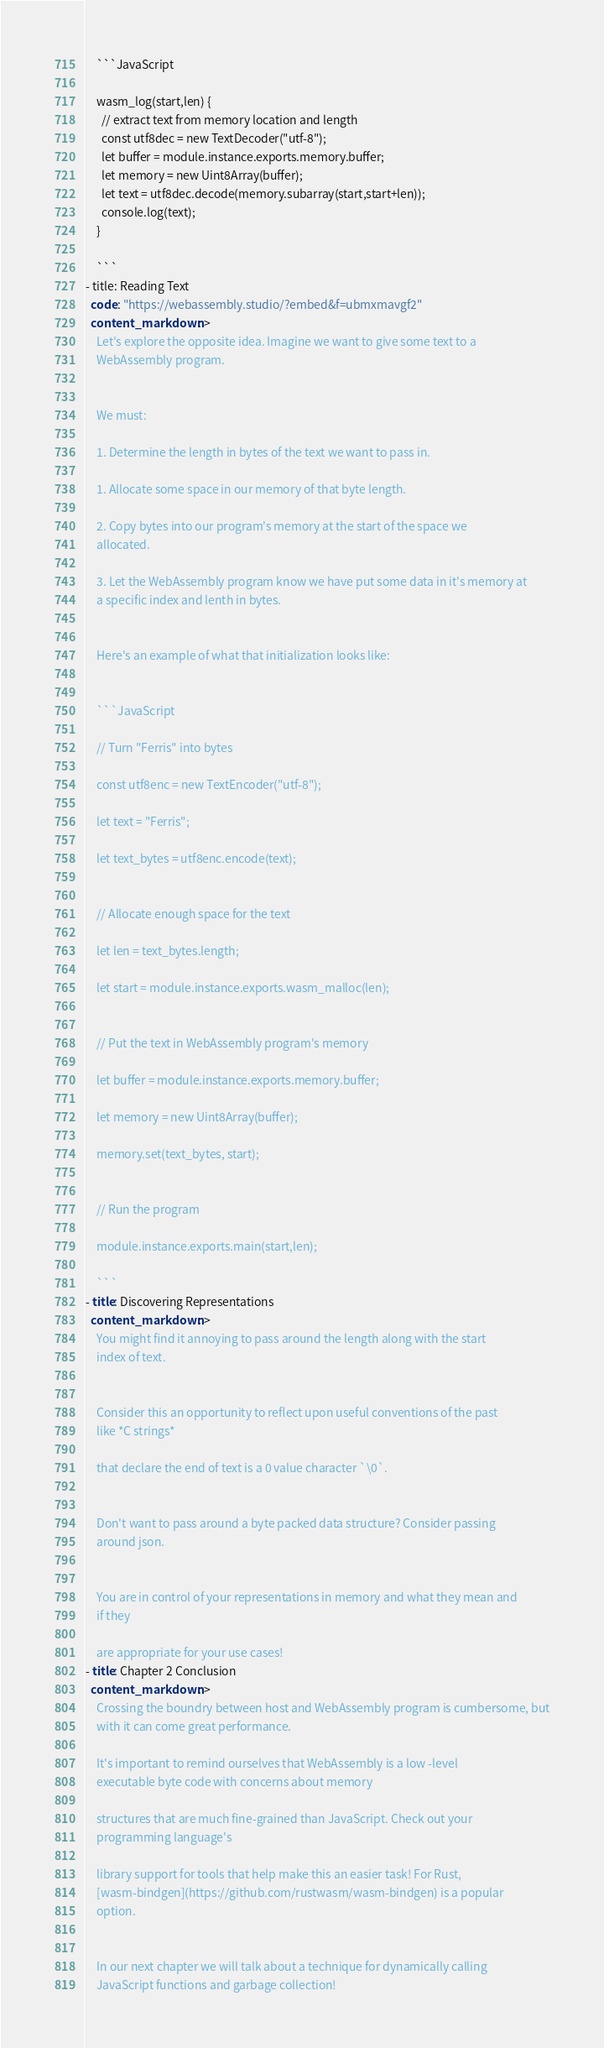Convert code to text. <code><loc_0><loc_0><loc_500><loc_500><_YAML_>

    ```JavaScript

    wasm_log(start,len) {
      // extract text from memory location and length
      const utf8dec = new TextDecoder("utf-8");
      let buffer = module.instance.exports.memory.buffer;
      let memory = new Uint8Array(buffer);
      let text = utf8dec.decode(memory.subarray(start,start+len));
      console.log(text);
    }

    ```
- title: Reading Text
  code: "https://webassembly.studio/?embed&f=ubmxmavgf2"
  content_markdown: >
    Let's explore the opposite idea. Imagine we want to give some text to a
    WebAssembly program.


    We must:

    1. Determine the length in bytes of the text we want to pass in.

    1. Allocate some space in our memory of that byte length.

    2. Copy bytes into our program's memory at the start of the space we
    allocated.

    3. Let the WebAssembly program know we have put some data in it's memory at
    a specific index and lenth in bytes. 


    Here's an example of what that initialization looks like:


    ```JavaScript

    // Turn "Ferris" into bytes

    const utf8enc = new TextEncoder("utf-8");

    let text = "Ferris";

    let text_bytes = utf8enc.encode(text);


    // Allocate enough space for the text

    let len = text_bytes.length;

    let start = module.instance.exports.wasm_malloc(len);


    // Put the text in WebAssembly program's memory

    let buffer = module.instance.exports.memory.buffer;

    let memory = new Uint8Array(buffer);

    memory.set(text_bytes, start);


    // Run the program

    module.instance.exports.main(start,len);

    ```
- title: Discovering Representations
  content_markdown: >
    You might find it annoying to pass around the length along with the start
    index of text.


    Consider this an opportunity to reflect upon useful conventions of the past
    like *C strings*

    that declare the end of text is a 0 value character `\0`.


    Don't want to pass around a byte packed data structure? Consider passing
    around json.


    You are in control of your representations in memory and what they mean and
    if they

    are appropriate for your use cases!
- title: Chapter 2 Conclusion
  content_markdown: >
    Crossing the boundry between host and WebAssembly program is cumbersome, but
    with it can come great performance. 

    It's important to remind ourselves that WebAssembly is a low -level
    executable byte code with concerns about memory

    structures that are much fine-grained than JavaScript. Check out your
    programming language's

    library support for tools that help make this an easier task! For Rust,
    [wasm-bindgen](https://github.com/rustwasm/wasm-bindgen) is a popular
    option.


    In our next chapter we will talk about a technique for dynamically calling
    JavaScript functions and garbage collection!
</code> 